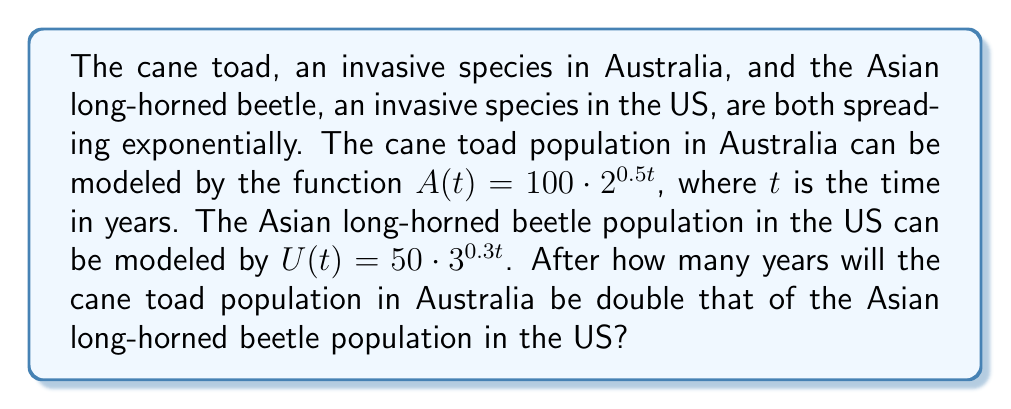Could you help me with this problem? Let's approach this step-by-step:

1) We need to find $t$ when $A(t) = 2U(t)$

2) Let's set up the equation:
   $100 \cdot 2^{0.5t} = 2(50 \cdot 3^{0.3t})$

3) Simplify the right side:
   $100 \cdot 2^{0.5t} = 100 \cdot 3^{0.3t}$

4) The 100 cancels out on both sides:
   $2^{0.5t} = 3^{0.3t}$

5) Take the natural log of both sides:
   $\ln(2^{0.5t}) = \ln(3^{0.3t})$

6) Use the log property $\ln(a^b) = b\ln(a)$:
   $0.5t \ln(2) = 0.3t \ln(3)$

7) Isolate $t$:
   $t(0.5 \ln(2) - 0.3 \ln(3)) = 0$
   $t = \frac{0}{0.5 \ln(2) - 0.3 \ln(3)}$

8) Calculate the value:
   $t \approx 14.4263$ years

9) Since we're dealing with populations, we should round up to the nearest whole year.
Answer: 15 years 